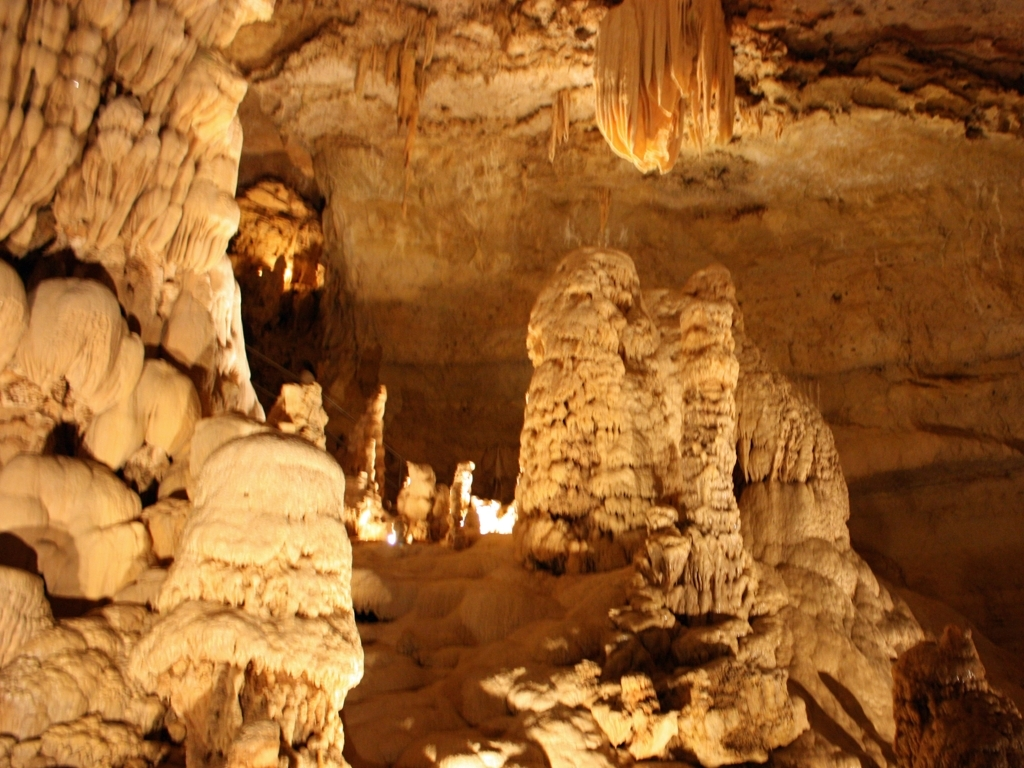What can you infer about the environment inside the cave? The environment inside the cave appears to be quite stable and undisturbed, as suggested by the intact and well-defined speleothems. The absence of disruptions indicates a lack of significant seismic activity or human interference. Conditions like constant temperature, high humidity, and slow-moving air flow seem prevalent, all contributing factors to the growth of these geological formations. 